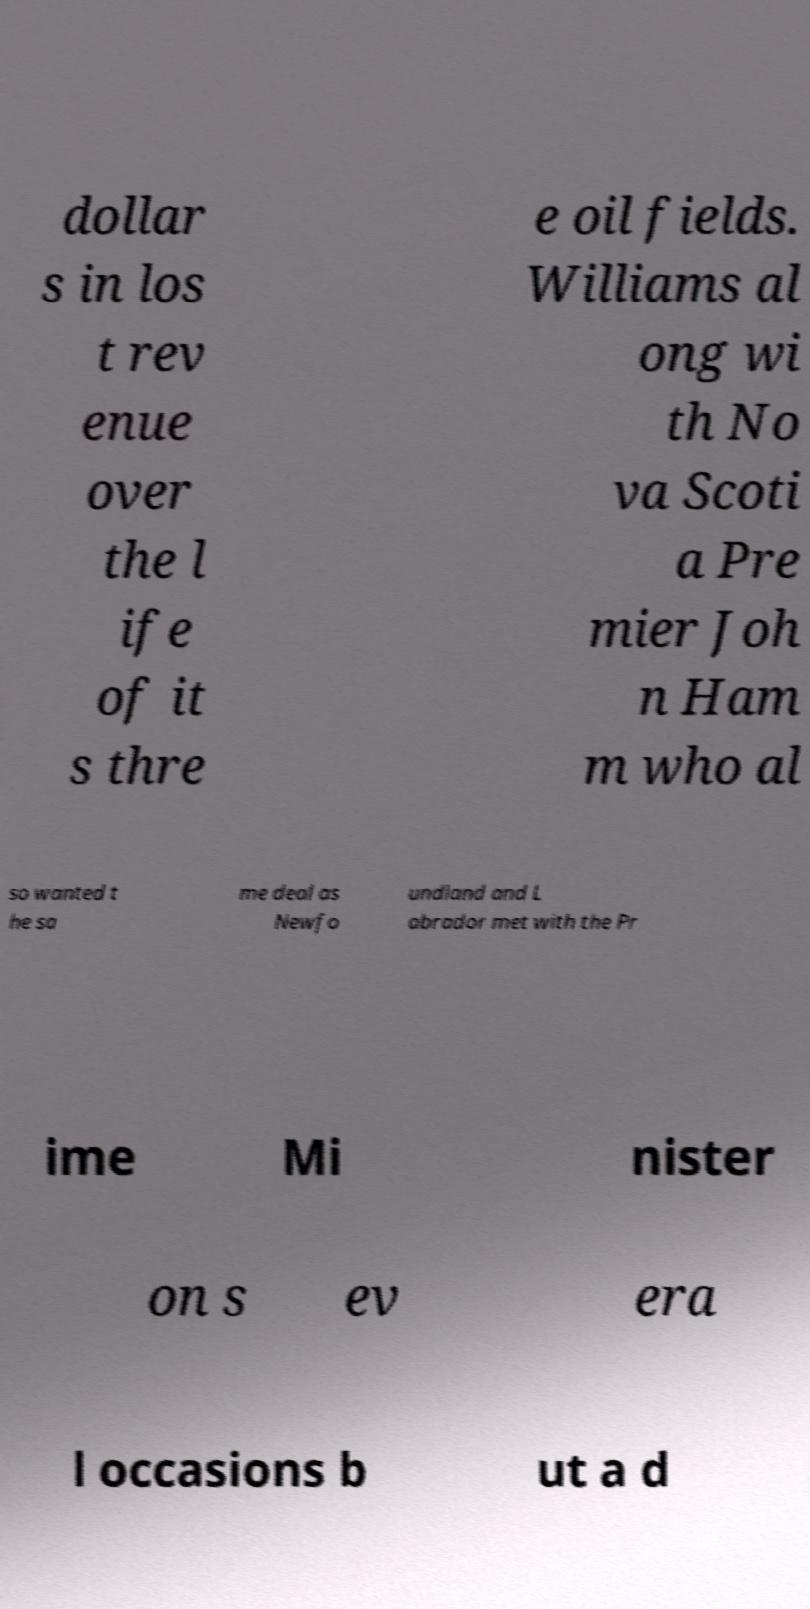Please read and relay the text visible in this image. What does it say? dollar s in los t rev enue over the l ife of it s thre e oil fields. Williams al ong wi th No va Scoti a Pre mier Joh n Ham m who al so wanted t he sa me deal as Newfo undland and L abrador met with the Pr ime Mi nister on s ev era l occasions b ut a d 